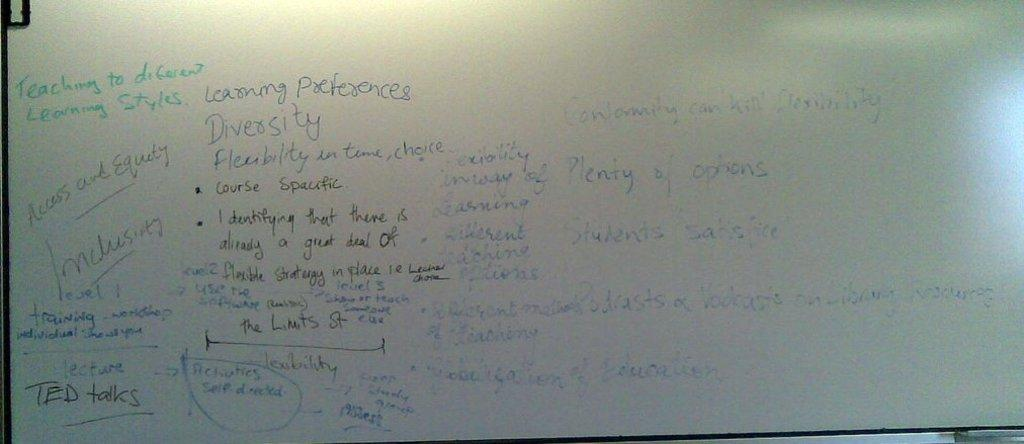<image>
Summarize the visual content of the image. A white board has lots of handwritten notes and it says Teaching to different learning styles. 